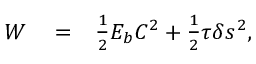Convert formula to latex. <formula><loc_0><loc_0><loc_500><loc_500>\begin{array} { r l r } { W } & = } & { \frac { 1 } { 2 } E _ { b } C ^ { 2 } + \frac { 1 } { 2 } \tau \delta s ^ { 2 } , } \end{array}</formula> 